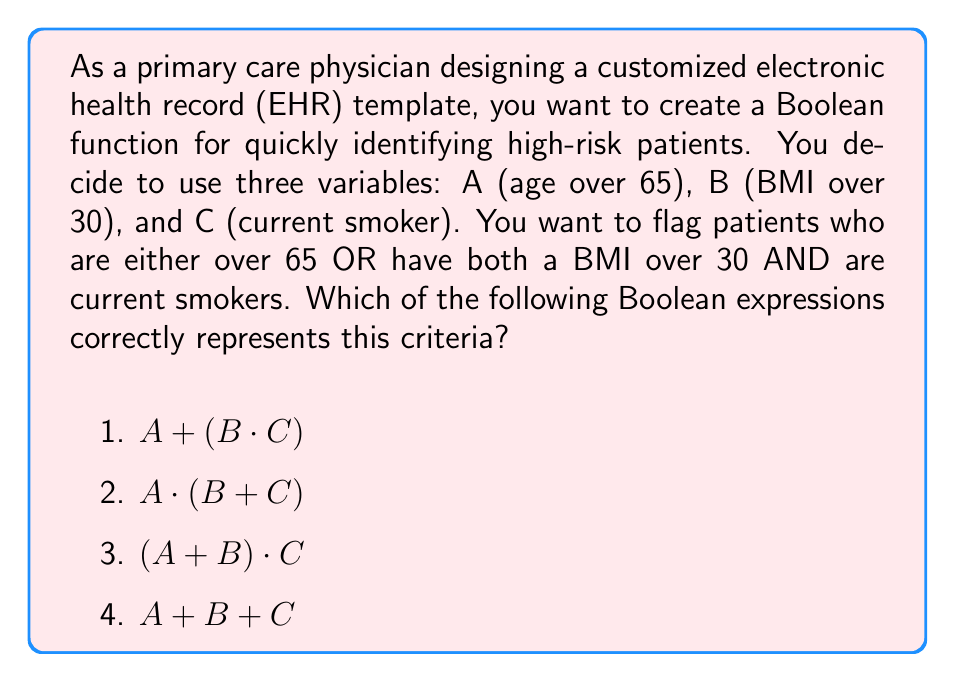Show me your answer to this math problem. Let's analyze this step-by-step:

1) First, we need to understand the criteria:
   - Flag patients who are over 65 (A) OR
   - Flag patients who have BOTH a BMI over 30 (B) AND are current smokers (C)

2) In Boolean algebra:
   - OR is represented by $+$
   - AND is represented by $\cdot$ (or multiplication)

3) Let's break down the criteria into Boolean expressions:
   - Over 65: $A$
   - BMI over 30 AND current smoker: $B \cdot C$

4) Now, we need to combine these with an OR operation:
   $A$ OR $(B \cdot C)$

5) In Boolean algebra, this is written as:
   $A + (B \cdot C)$

6) Analyzing the given options:
   1) $A + (B \cdot C)$ - This matches our derived expression
   2) $A \cdot (B + C)$ - This would flag patients who are over 65 AND (have BMI over 30 OR are smokers), which is not what we want
   3) $(A + B) \cdot C$ - This would flag patients who are (over 65 OR have BMI over 30) AND are smokers, which is not correct
   4) $A + B + C$ - This would flag patients who are either over 65 OR have BMI over 30 OR are smokers, which is too broad

Therefore, the correct Boolean expression is option 1: $A + (B \cdot C)$
Answer: $A + (B \cdot C)$ 